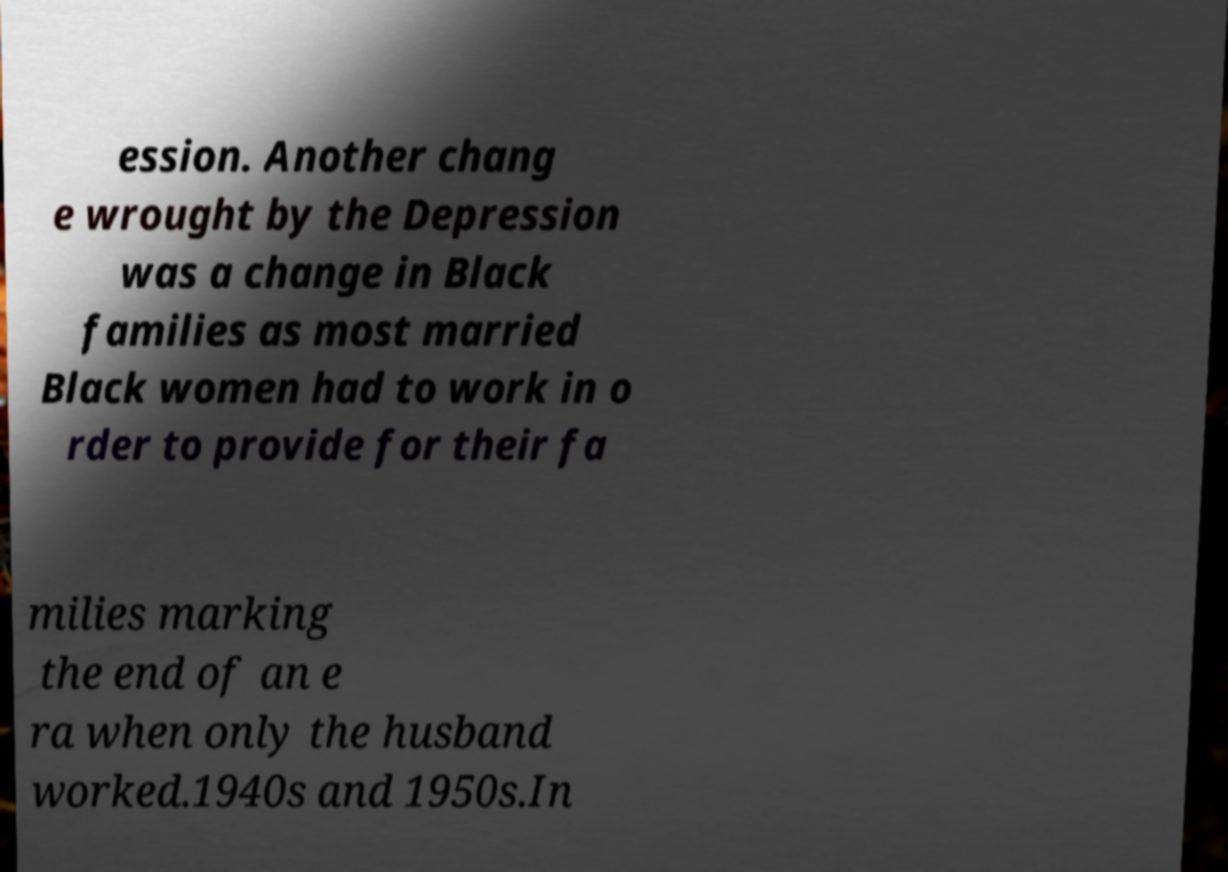Can you accurately transcribe the text from the provided image for me? ession. Another chang e wrought by the Depression was a change in Black families as most married Black women had to work in o rder to provide for their fa milies marking the end of an e ra when only the husband worked.1940s and 1950s.In 